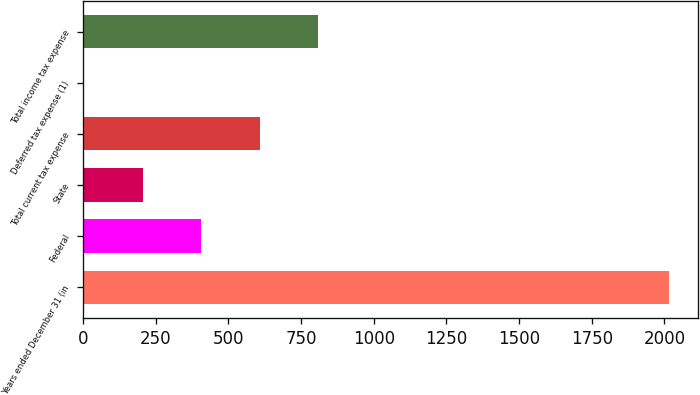Convert chart. <chart><loc_0><loc_0><loc_500><loc_500><bar_chart><fcel>Years ended December 31 (in<fcel>Federal<fcel>State<fcel>Total current tax expense<fcel>Deferred tax expense (1)<fcel>Total income tax expense<nl><fcel>2016<fcel>406.16<fcel>204.93<fcel>607.39<fcel>3.7<fcel>808.62<nl></chart> 